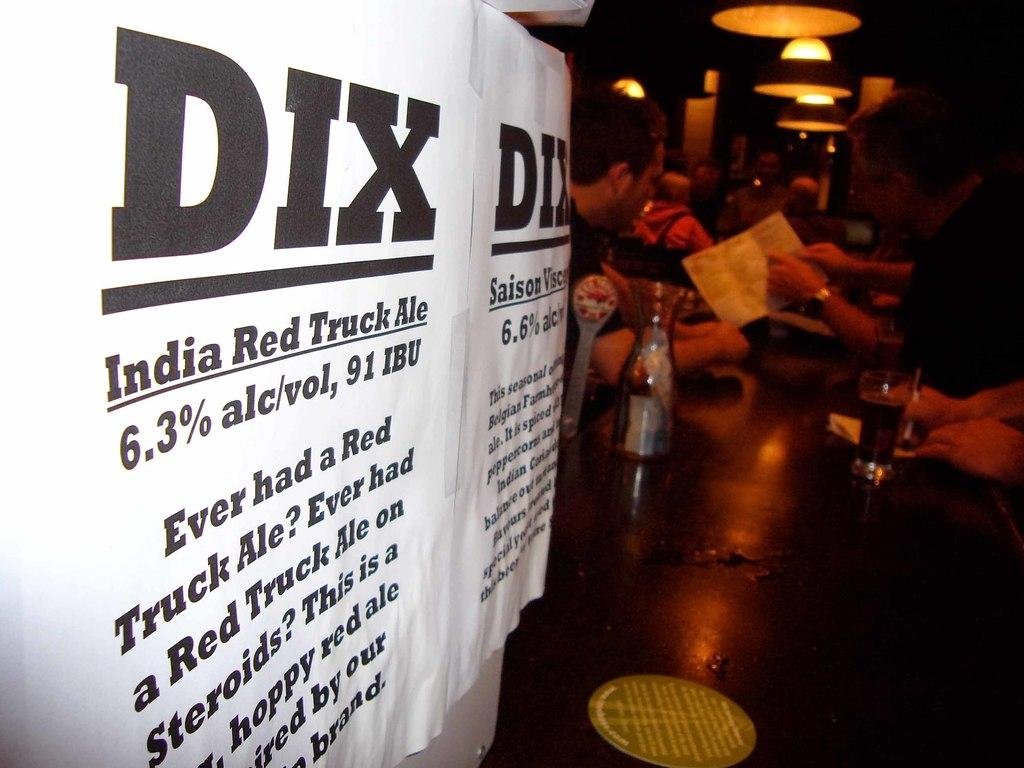<image>
Give a short and clear explanation of the subsequent image. India Red Truck Ale flyers are at the foreground of this bar table. 